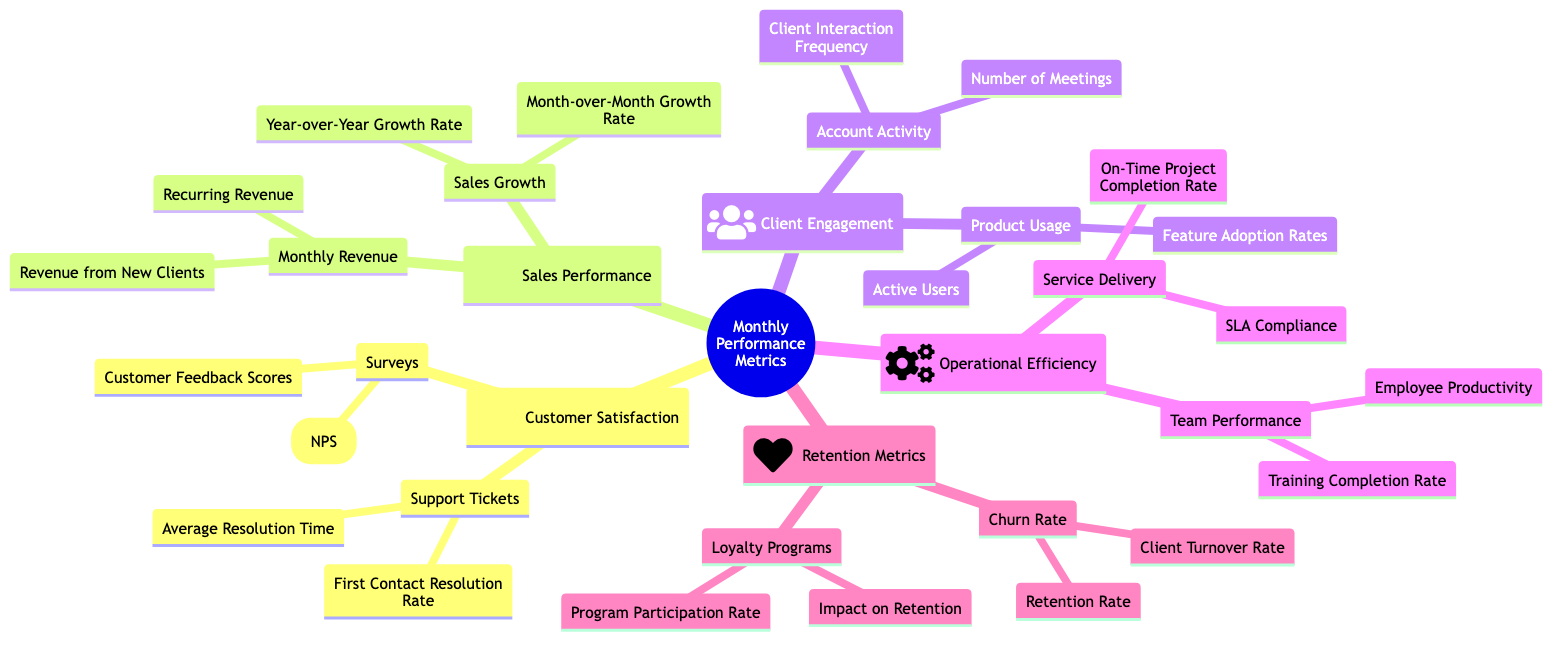What are the two categories under Customer Satisfaction? The diagram shows two main categories under Customer Satisfaction: Surveys and Support Tickets.
Answer: Surveys, Support Tickets What is the icon associated with Operational Efficiency? The diagram indicates that Operational Efficiency is represented with a gear icon (cogs).
Answer: cogs How many metrics are listed under Sales Performance? Under Sales Performance, there are two main categories: Monthly Revenue and Sales Growth, which together contain four metrics.
Answer: 4 What is the metric associated with Retention Metrics that evaluates the likelihood of clients staying? Under Retention Metrics, the metric that evaluates the likelihood of clients staying is the Retention Rate.
Answer: Retention Rate What is the relationship between Monthly Revenue and Sales Growth in the diagram? Monthly Revenue and Sales Growth are both subcategories under Sales Performance, indicating they are related to measuring sales outcomes.
Answer: Related What are the two components of Support Tickets? Support Tickets in the diagram consists of Average Resolution Time and First Contact Resolution Rate.
Answer: Average Resolution Time, First Contact Resolution Rate What can be inferred about the focus of Client Engagement metrics? The Client Engagement metrics focus on Account Activity and Product Usage, suggesting an emphasis on interactions and usage tracking.
Answer: Interactions and usage tracking Which metric could indicate potential issues in customer service responsiveness? Average Resolution Time under Support Tickets is a key metric that indicates potential issues in customer service responsiveness.
Answer: Average Resolution Time What metric under Operational Efficiency reflects employee development? The Training Completion Rate under Team Performance reflects employee development within Operational Efficiency.
Answer: Training Completion Rate How many types of Surveys are included in Customer Satisfaction? There are two types of Surveys mentioned in the diagram: Customer Feedback Scores and Net Promoter Score (NPS).
Answer: 2 